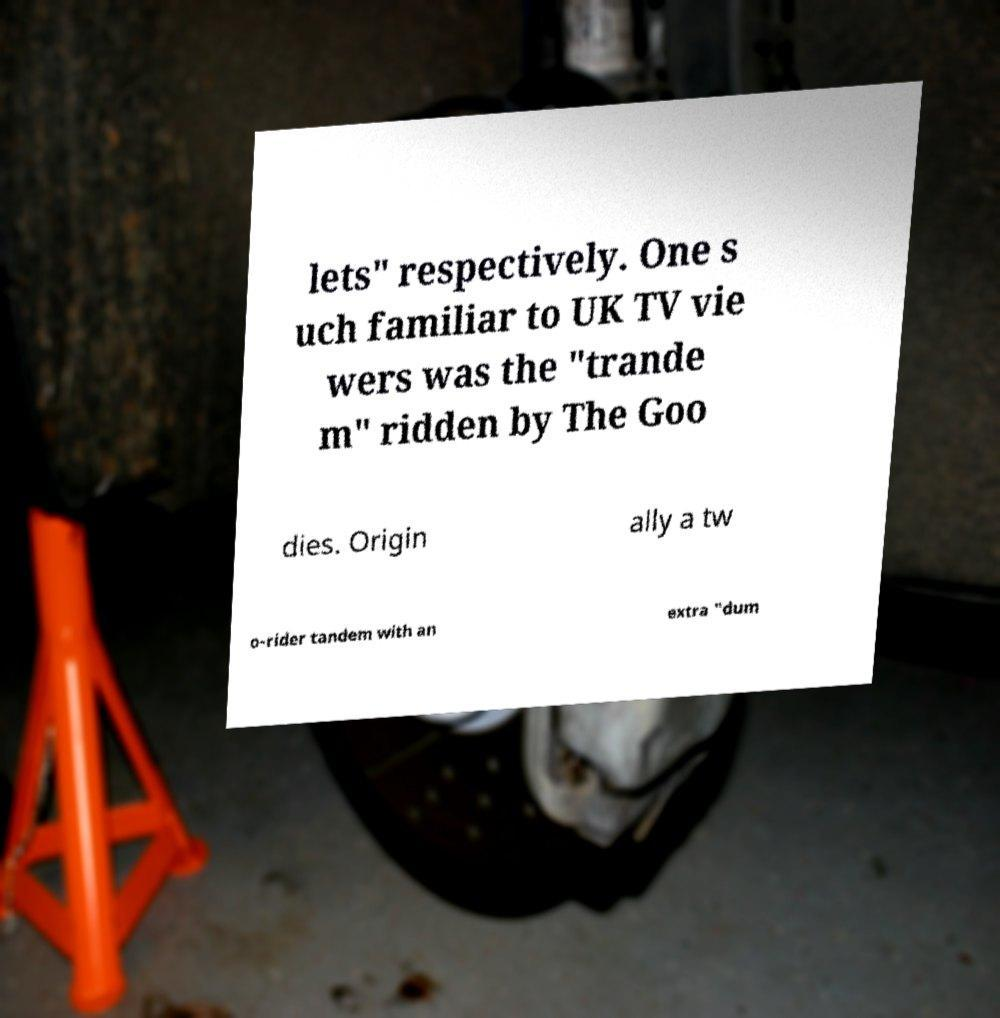Could you assist in decoding the text presented in this image and type it out clearly? lets" respectively. One s uch familiar to UK TV vie wers was the "trande m" ridden by The Goo dies. Origin ally a tw o-rider tandem with an extra "dum 